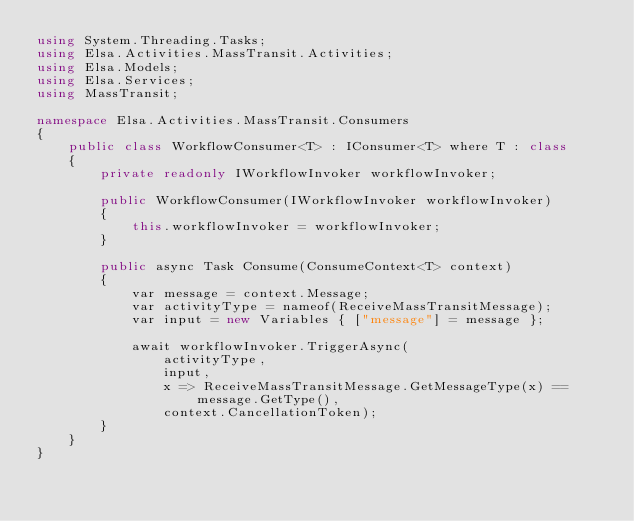<code> <loc_0><loc_0><loc_500><loc_500><_C#_>using System.Threading.Tasks;
using Elsa.Activities.MassTransit.Activities;
using Elsa.Models;
using Elsa.Services;
using MassTransit;

namespace Elsa.Activities.MassTransit.Consumers
{
    public class WorkflowConsumer<T> : IConsumer<T> where T : class
    {
        private readonly IWorkflowInvoker workflowInvoker;

        public WorkflowConsumer(IWorkflowInvoker workflowInvoker)
        {
            this.workflowInvoker = workflowInvoker;
        }
        
        public async Task Consume(ConsumeContext<T> context)
        {
            var message = context.Message;
            var activityType = nameof(ReceiveMassTransitMessage);
            var input = new Variables { ["message"] = message };
            
            await workflowInvoker.TriggerAsync(
                activityType, 
                input,
                x => ReceiveMassTransitMessage.GetMessageType(x) == message.GetType(),
                context.CancellationToken);
        }
    }
}</code> 